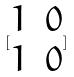<formula> <loc_0><loc_0><loc_500><loc_500>[ \begin{matrix} 1 & 0 \\ 1 & 0 \end{matrix} ]</formula> 